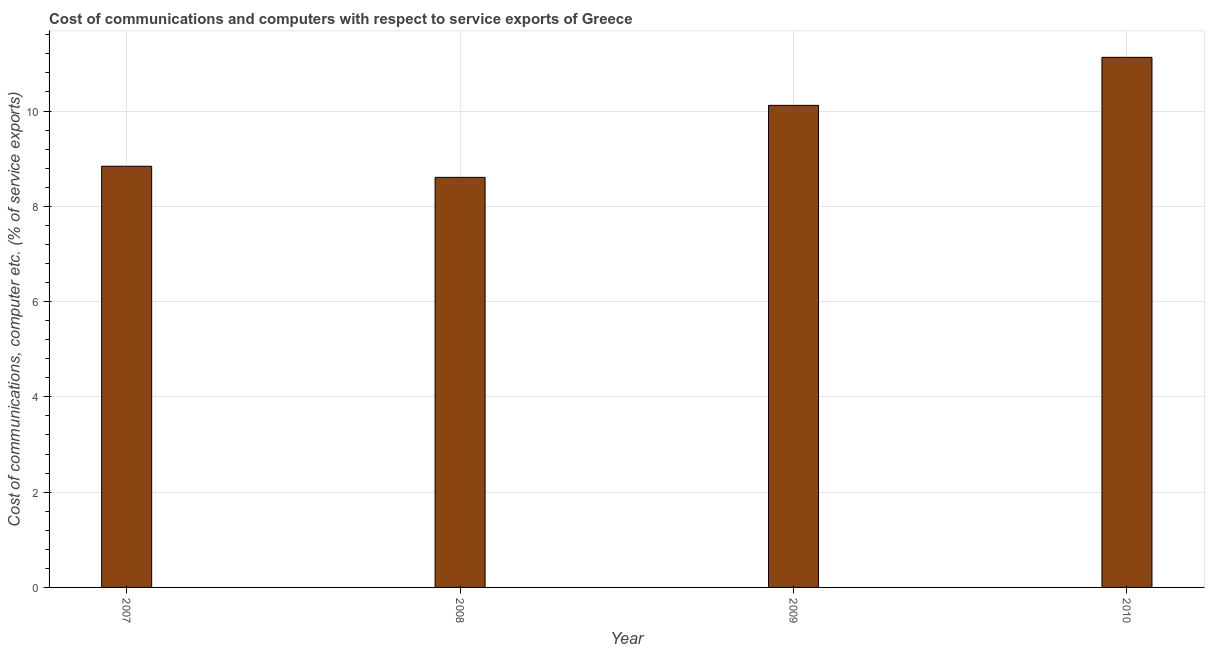Does the graph contain any zero values?
Provide a succinct answer. No. Does the graph contain grids?
Keep it short and to the point. Yes. What is the title of the graph?
Your answer should be compact. Cost of communications and computers with respect to service exports of Greece. What is the label or title of the Y-axis?
Ensure brevity in your answer.  Cost of communications, computer etc. (% of service exports). What is the cost of communications and computer in 2007?
Offer a terse response. 8.84. Across all years, what is the maximum cost of communications and computer?
Offer a terse response. 11.13. Across all years, what is the minimum cost of communications and computer?
Give a very brief answer. 8.61. In which year was the cost of communications and computer maximum?
Your answer should be compact. 2010. What is the sum of the cost of communications and computer?
Your answer should be very brief. 38.7. What is the difference between the cost of communications and computer in 2007 and 2009?
Offer a very short reply. -1.28. What is the average cost of communications and computer per year?
Your answer should be very brief. 9.67. What is the median cost of communications and computer?
Provide a succinct answer. 9.48. In how many years, is the cost of communications and computer greater than 2.4 %?
Provide a short and direct response. 4. Do a majority of the years between 2009 and 2007 (inclusive) have cost of communications and computer greater than 1.2 %?
Provide a succinct answer. Yes. What is the ratio of the cost of communications and computer in 2008 to that in 2010?
Your answer should be compact. 0.77. Is the cost of communications and computer in 2008 less than that in 2010?
Your answer should be compact. Yes. Is the difference between the cost of communications and computer in 2007 and 2010 greater than the difference between any two years?
Your answer should be compact. No. What is the difference between the highest and the second highest cost of communications and computer?
Give a very brief answer. 1.01. What is the difference between the highest and the lowest cost of communications and computer?
Offer a terse response. 2.52. How many bars are there?
Make the answer very short. 4. What is the difference between two consecutive major ticks on the Y-axis?
Your answer should be very brief. 2. What is the Cost of communications, computer etc. (% of service exports) in 2007?
Offer a terse response. 8.84. What is the Cost of communications, computer etc. (% of service exports) of 2008?
Keep it short and to the point. 8.61. What is the Cost of communications, computer etc. (% of service exports) of 2009?
Keep it short and to the point. 10.12. What is the Cost of communications, computer etc. (% of service exports) in 2010?
Your answer should be very brief. 11.13. What is the difference between the Cost of communications, computer etc. (% of service exports) in 2007 and 2008?
Offer a very short reply. 0.23. What is the difference between the Cost of communications, computer etc. (% of service exports) in 2007 and 2009?
Your answer should be very brief. -1.28. What is the difference between the Cost of communications, computer etc. (% of service exports) in 2007 and 2010?
Make the answer very short. -2.29. What is the difference between the Cost of communications, computer etc. (% of service exports) in 2008 and 2009?
Your answer should be very brief. -1.51. What is the difference between the Cost of communications, computer etc. (% of service exports) in 2008 and 2010?
Your answer should be compact. -2.52. What is the difference between the Cost of communications, computer etc. (% of service exports) in 2009 and 2010?
Give a very brief answer. -1.01. What is the ratio of the Cost of communications, computer etc. (% of service exports) in 2007 to that in 2009?
Make the answer very short. 0.87. What is the ratio of the Cost of communications, computer etc. (% of service exports) in 2007 to that in 2010?
Your answer should be very brief. 0.8. What is the ratio of the Cost of communications, computer etc. (% of service exports) in 2008 to that in 2009?
Provide a succinct answer. 0.85. What is the ratio of the Cost of communications, computer etc. (% of service exports) in 2008 to that in 2010?
Keep it short and to the point. 0.77. What is the ratio of the Cost of communications, computer etc. (% of service exports) in 2009 to that in 2010?
Provide a succinct answer. 0.91. 